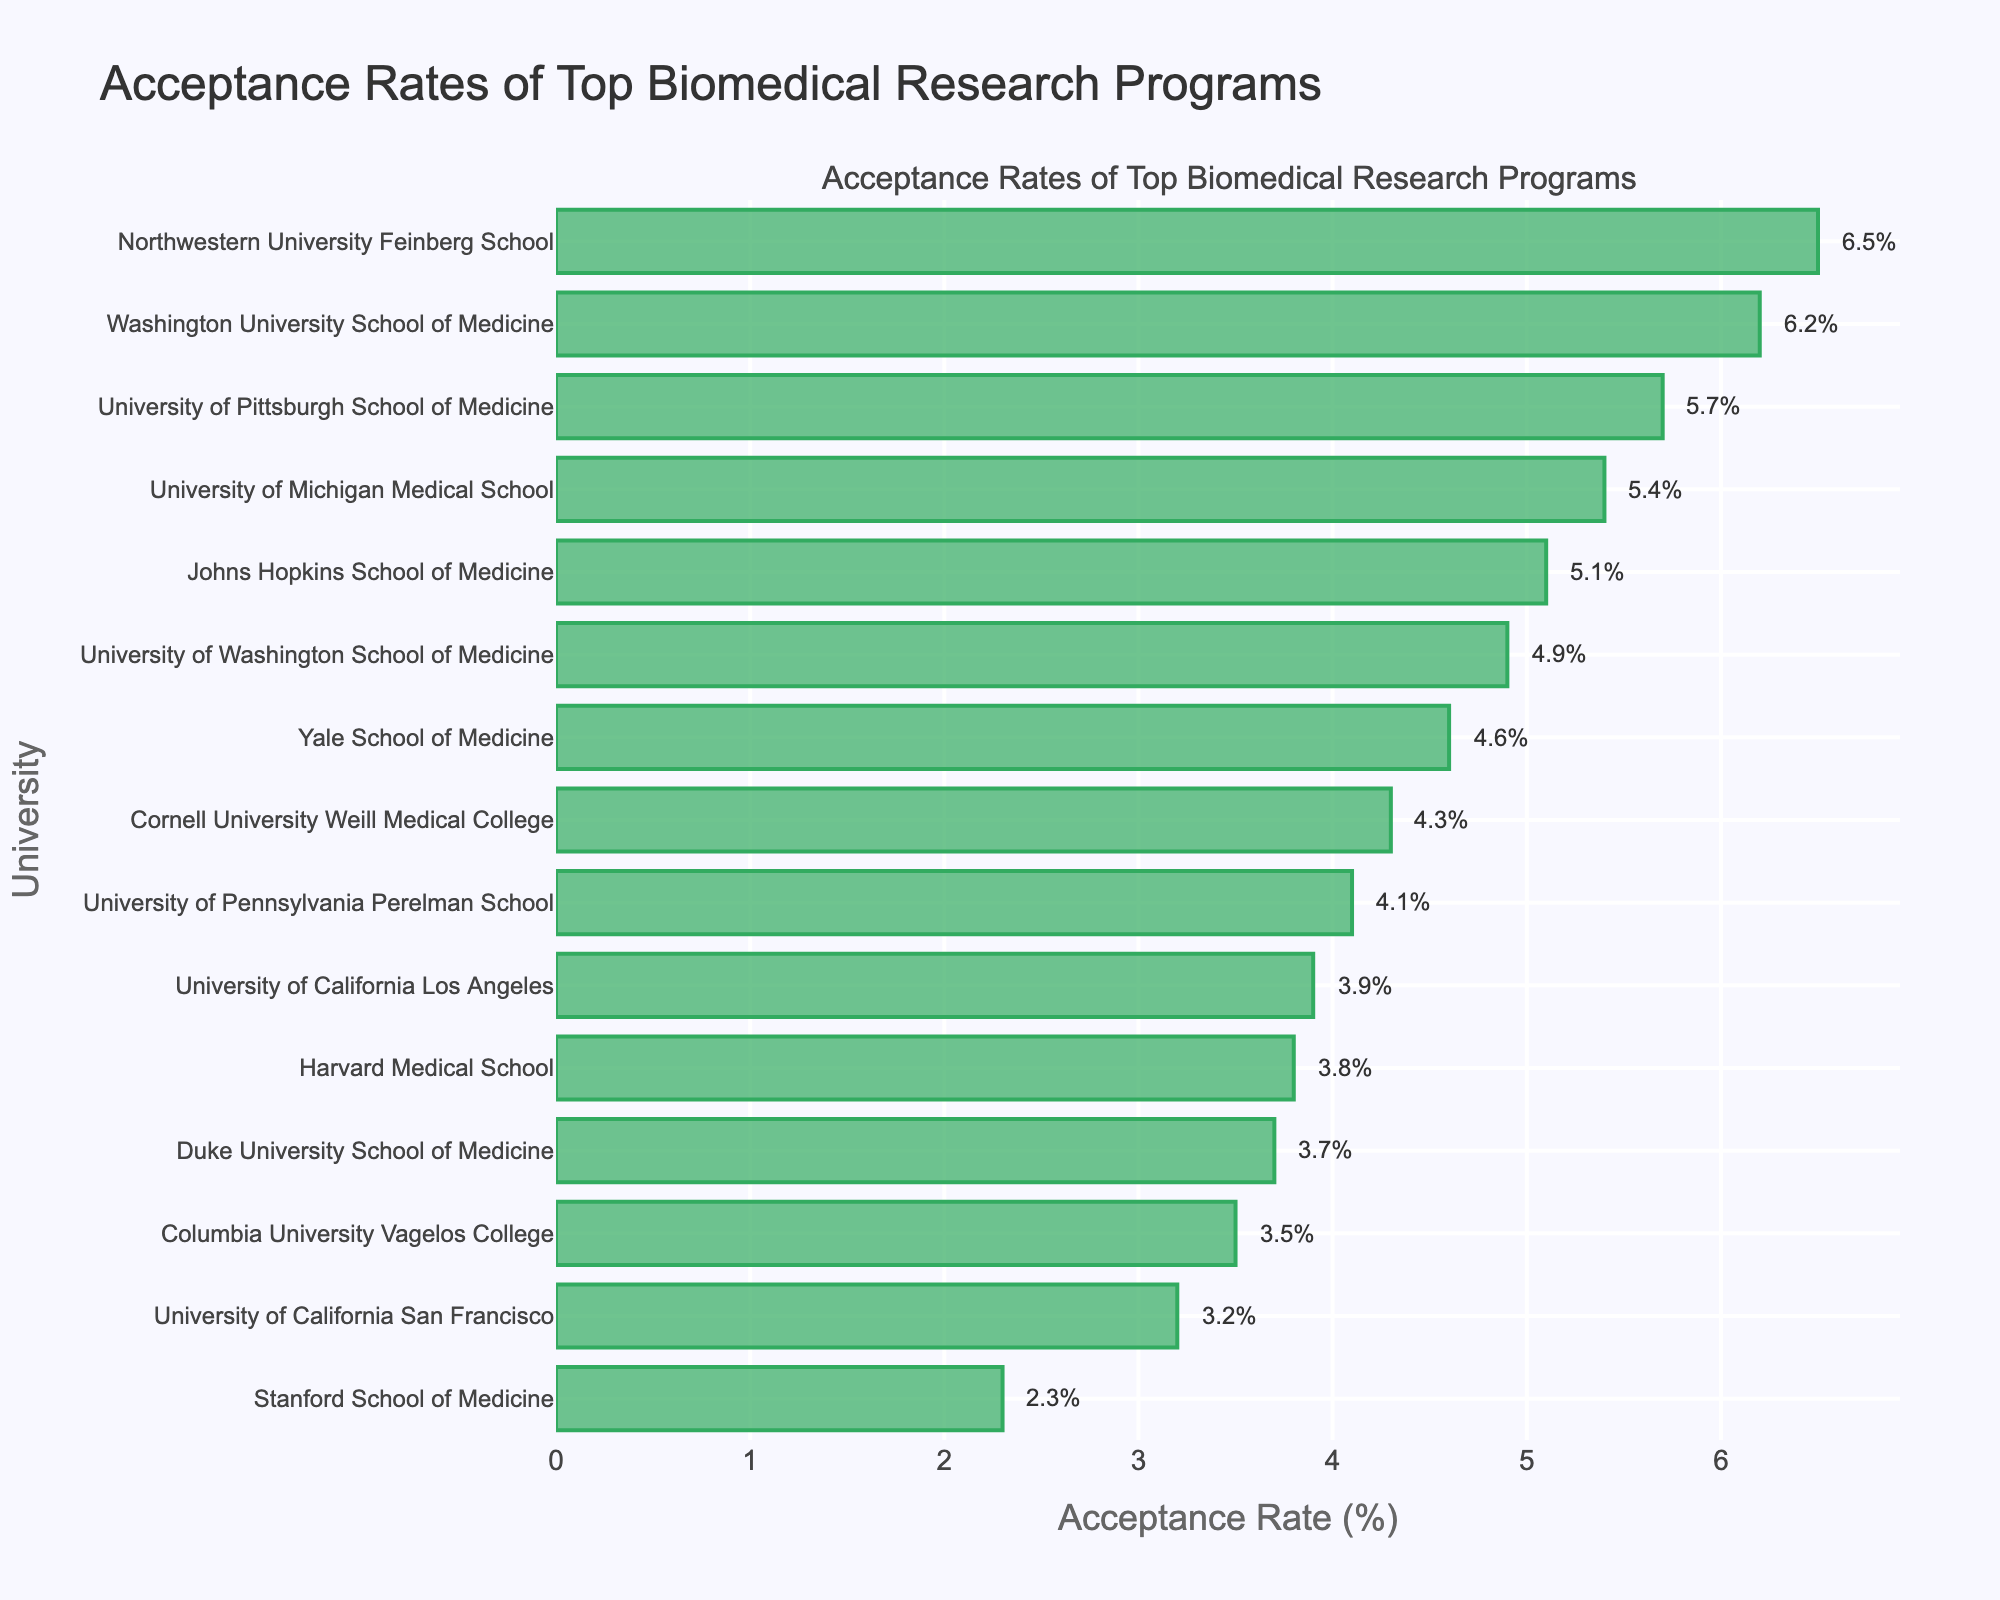What's the acceptance rate of Stanford School of Medicine? Locate Stanford School of Medicine on the y-axis, then refer to the corresponding bar on the x-axis. The text annotation shows the acceptance rate as 2.3%.
Answer: 2.3% Which university has the highest acceptance rate and what is it? Find the longest horizontal bar in the chart, which is located at the top (Washington University School of Medicine). The text annotation indicates an acceptance rate of 6.5%.
Answer: Washington University School of Medicine, 6.5% What is the difference in acceptance rates between Harvard Medical School and University of Pennsylvania Perelman School? Identify the bars for both Harvard Medical School (3.8%) and University of Pennsylvania Perelman School (4.1%). Subtract Harvard's rate from Pennsylvania's rate: 4.1% - 3.8% = 0.3%.
Answer: 0.3% Which university has a lower acceptance rate: Yale School of Medicine or University of California San Francisco? Compare the bars for Yale School of Medicine (4.6%) and University of California San Francisco (3.2%). University of California San Francisco has a lower rate.
Answer: University of California San Francisco How many universities have an acceptance rate lower than 4%? Identify all bars with acceptance rates below 4%. These universities are: Stanford School of Medicine (2.3%), Harvard Medical School (3.8%), University of California San Francisco (3.2%), Columbia University Vagelos College (3.5%), Duke University School of Medicine (3.7%), and University of California Los Angeles (3.9%). Count these universities: 6.
Answer: 6 What is the average acceptance rate for all listed universities? Sum all acceptance rates: 3.8 + 2.3 + 5.1 + 3.2 + 4.6 + 3.5 + 4.9 + 3.7 + 4.1 + 6.2 + 5.4 + 4.3 + 3.9 + 6.5 + 5.7 = 67.2. Divide by the number of universities (15): 67.2 / 15 = 4.48%.
Answer: 4.48% Which universities have acceptance rates close to 5% (within 0.1%)? Identify bars with acceptance rates between 4.9% and 5.1%. These universities are: Johns Hopkins School of Medicine (5.1%) and University of Washington School of Medicine (4.9%).
Answer: Johns Hopkins School of Medicine, University of Washington School of Medicine 